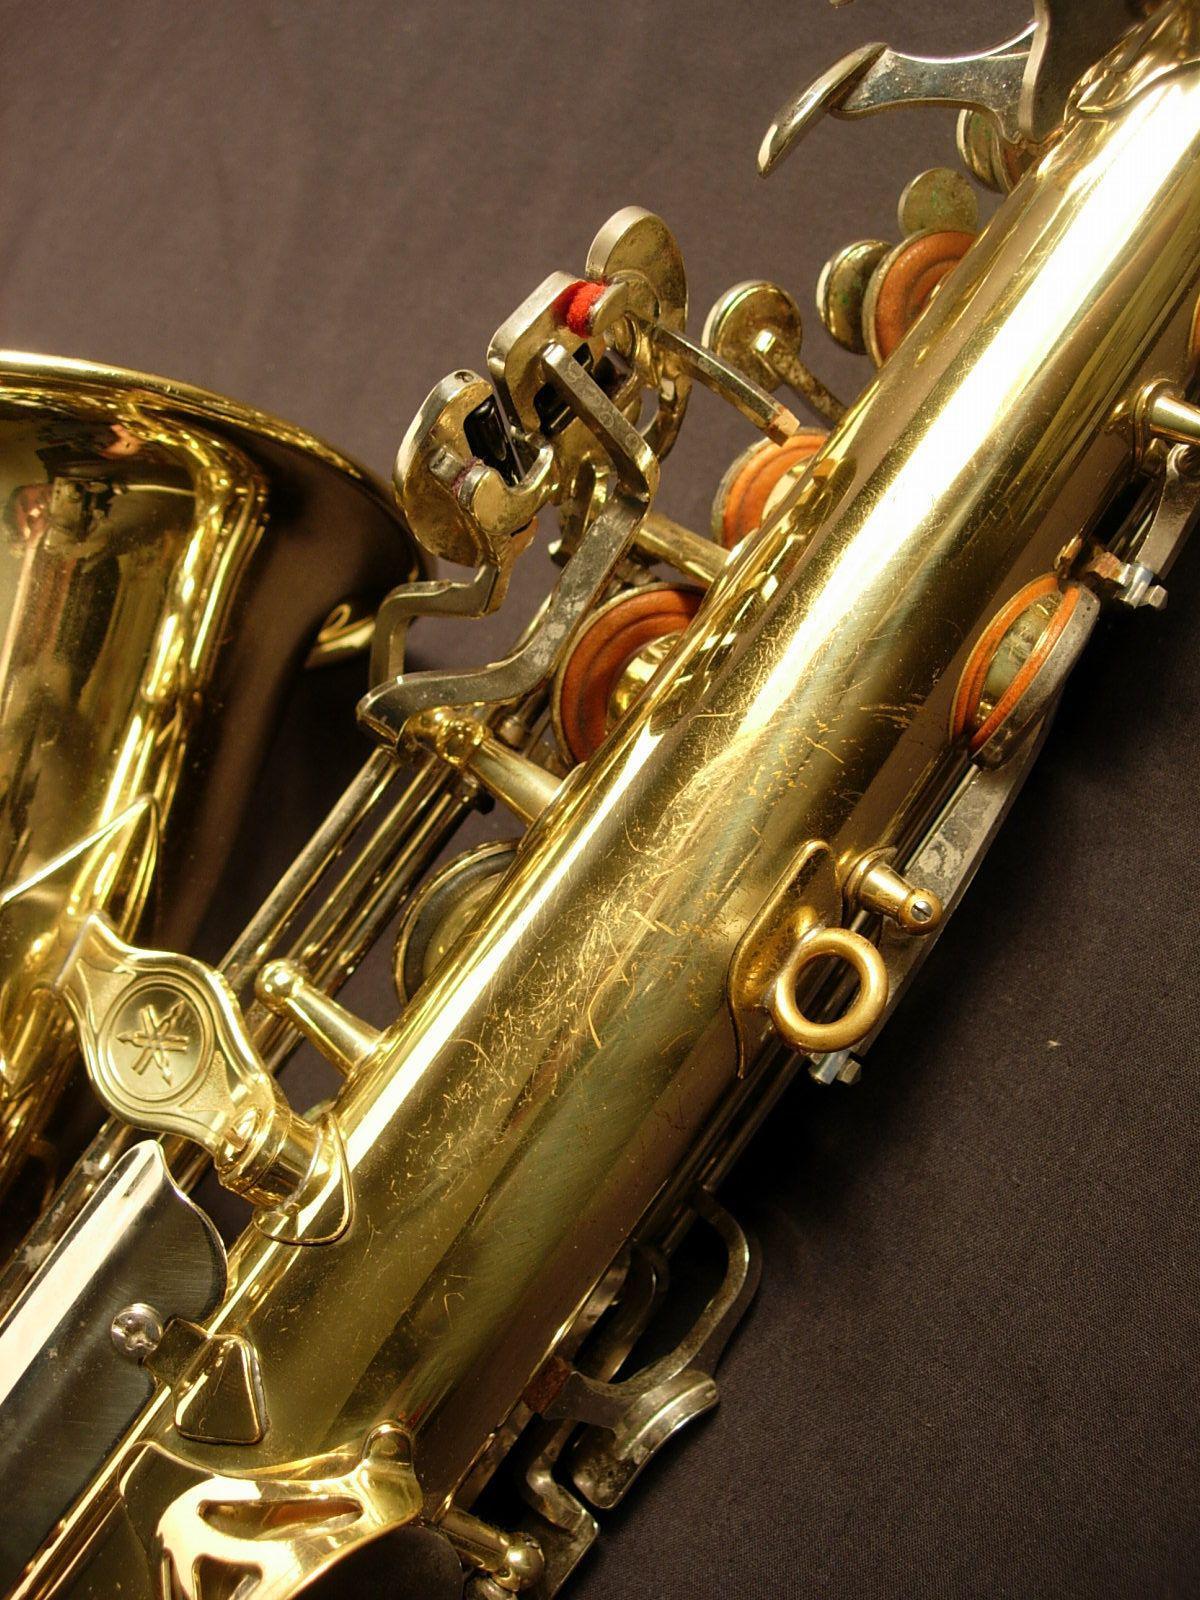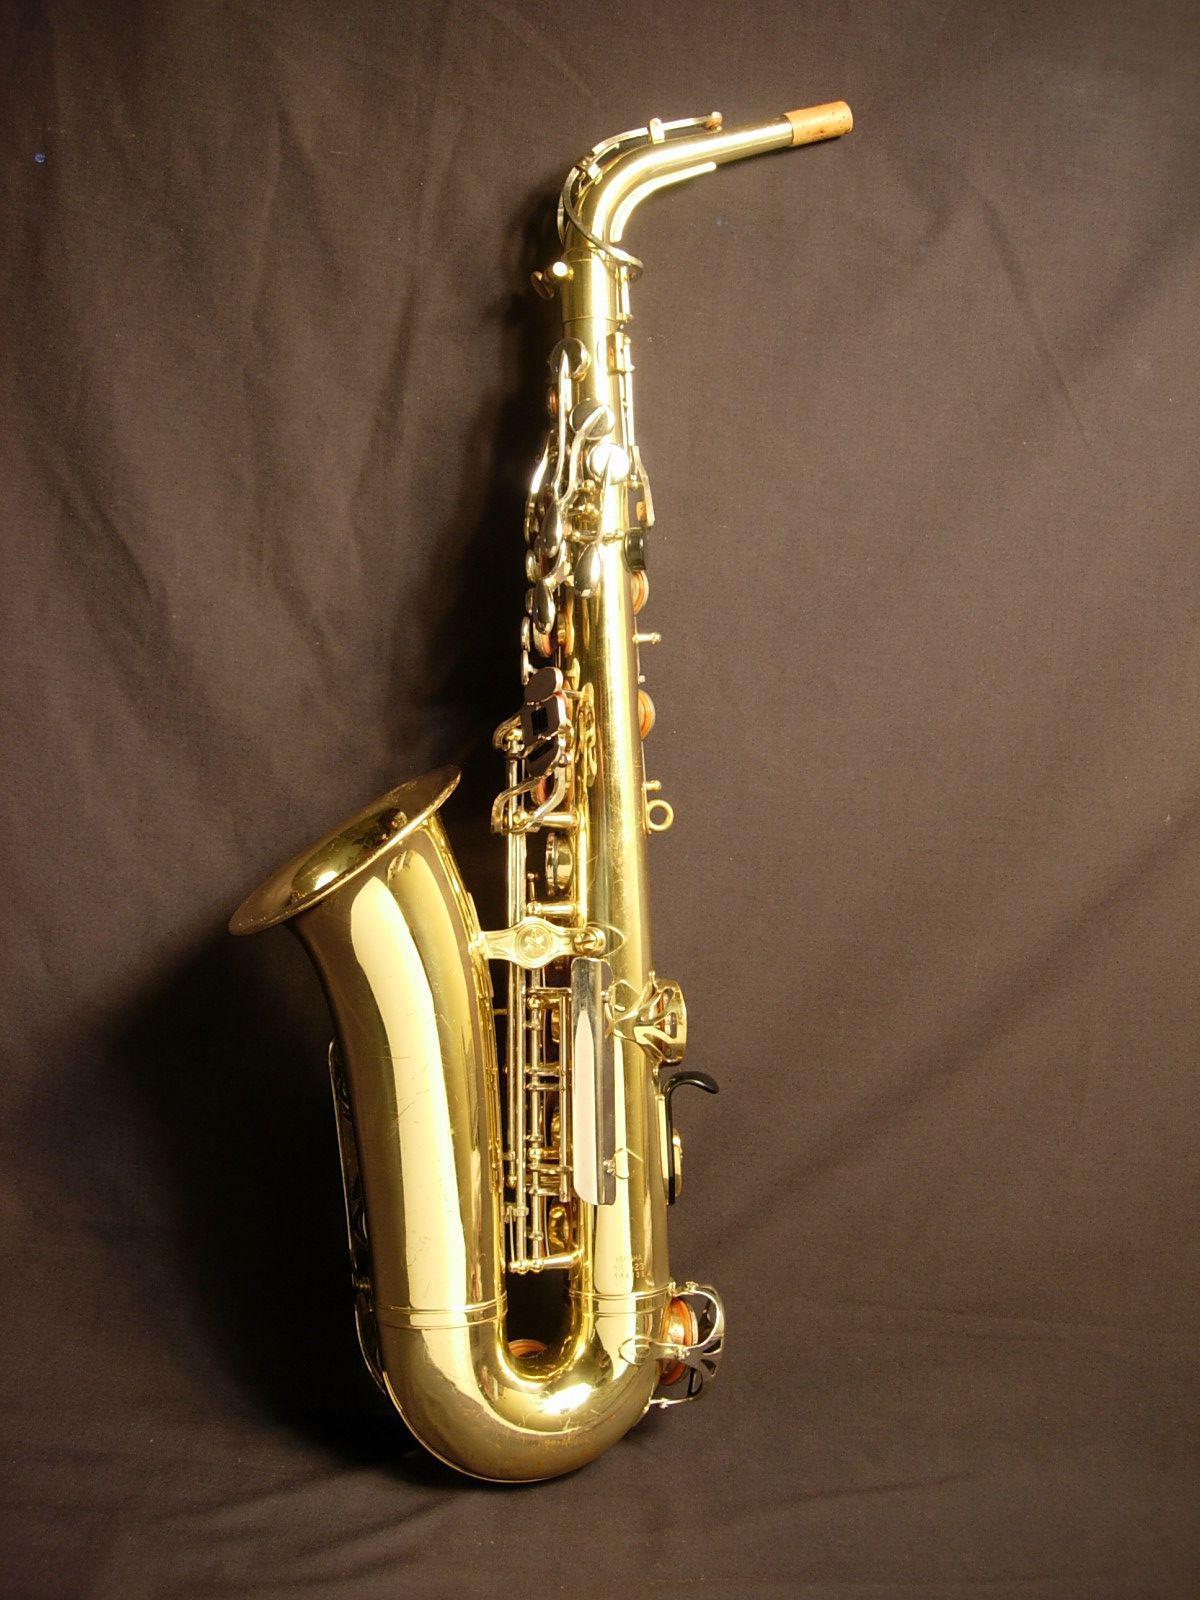The first image is the image on the left, the second image is the image on the right. Analyze the images presented: Is the assertion "There is a black mouthpiece pointing left atop the gold or brass saxophone." valid? Answer yes or no. No. The first image is the image on the left, the second image is the image on the right. Considering the images on both sides, is "At least two saxophones face left." valid? Answer yes or no. Yes. 